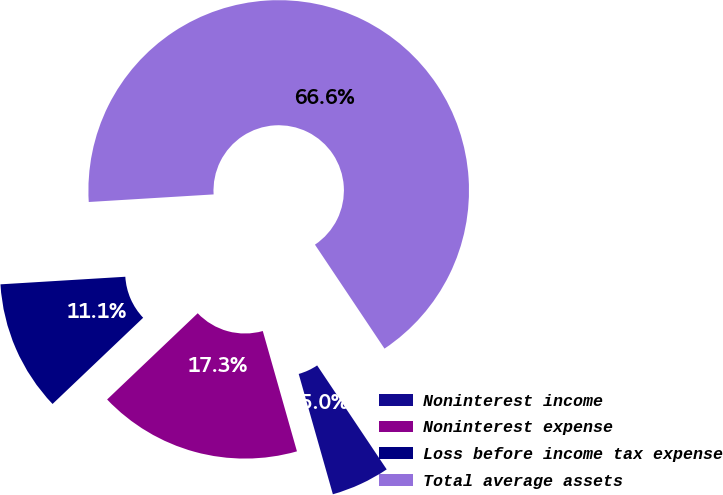Convert chart to OTSL. <chart><loc_0><loc_0><loc_500><loc_500><pie_chart><fcel>Noninterest income<fcel>Noninterest expense<fcel>Loss before income tax expense<fcel>Total average assets<nl><fcel>4.98%<fcel>17.3%<fcel>11.14%<fcel>66.59%<nl></chart> 